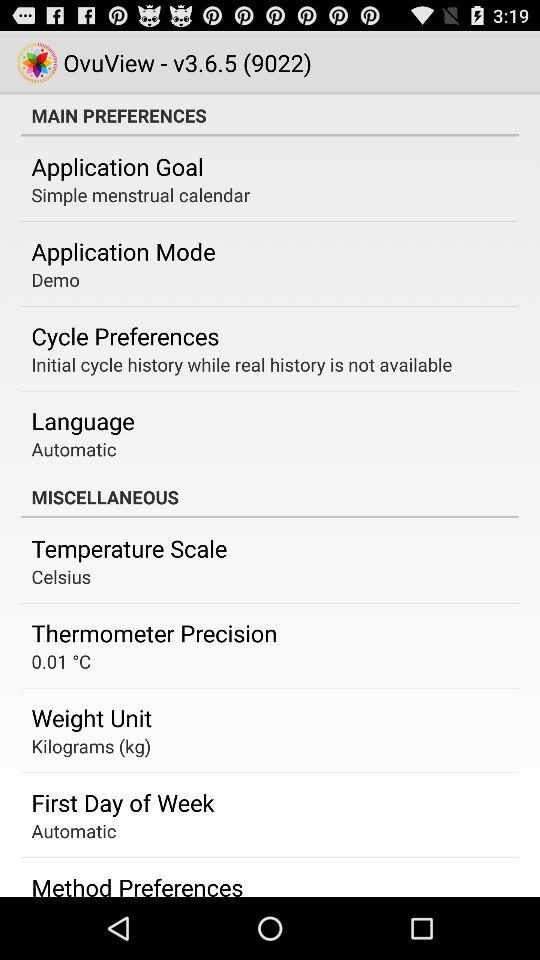Which language is selected? The selected language is automatic. 